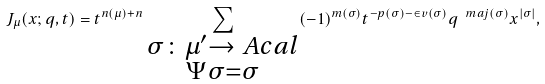<formula> <loc_0><loc_0><loc_500><loc_500>J _ { \mu } ( x ; q , t ) = t ^ { n ( \mu ) + n } \sum _ { \substack { \sigma \colon \mu ^ { \prime } \rightarrow \ A c a l \\ \Psi \sigma = \sigma } } ( - 1 ) ^ { m ( \sigma ) } t ^ { - p ( \sigma ) - \in v ( \sigma ) } q ^ { \ m a j ( \sigma ) } x ^ { | \sigma | } ,</formula> 